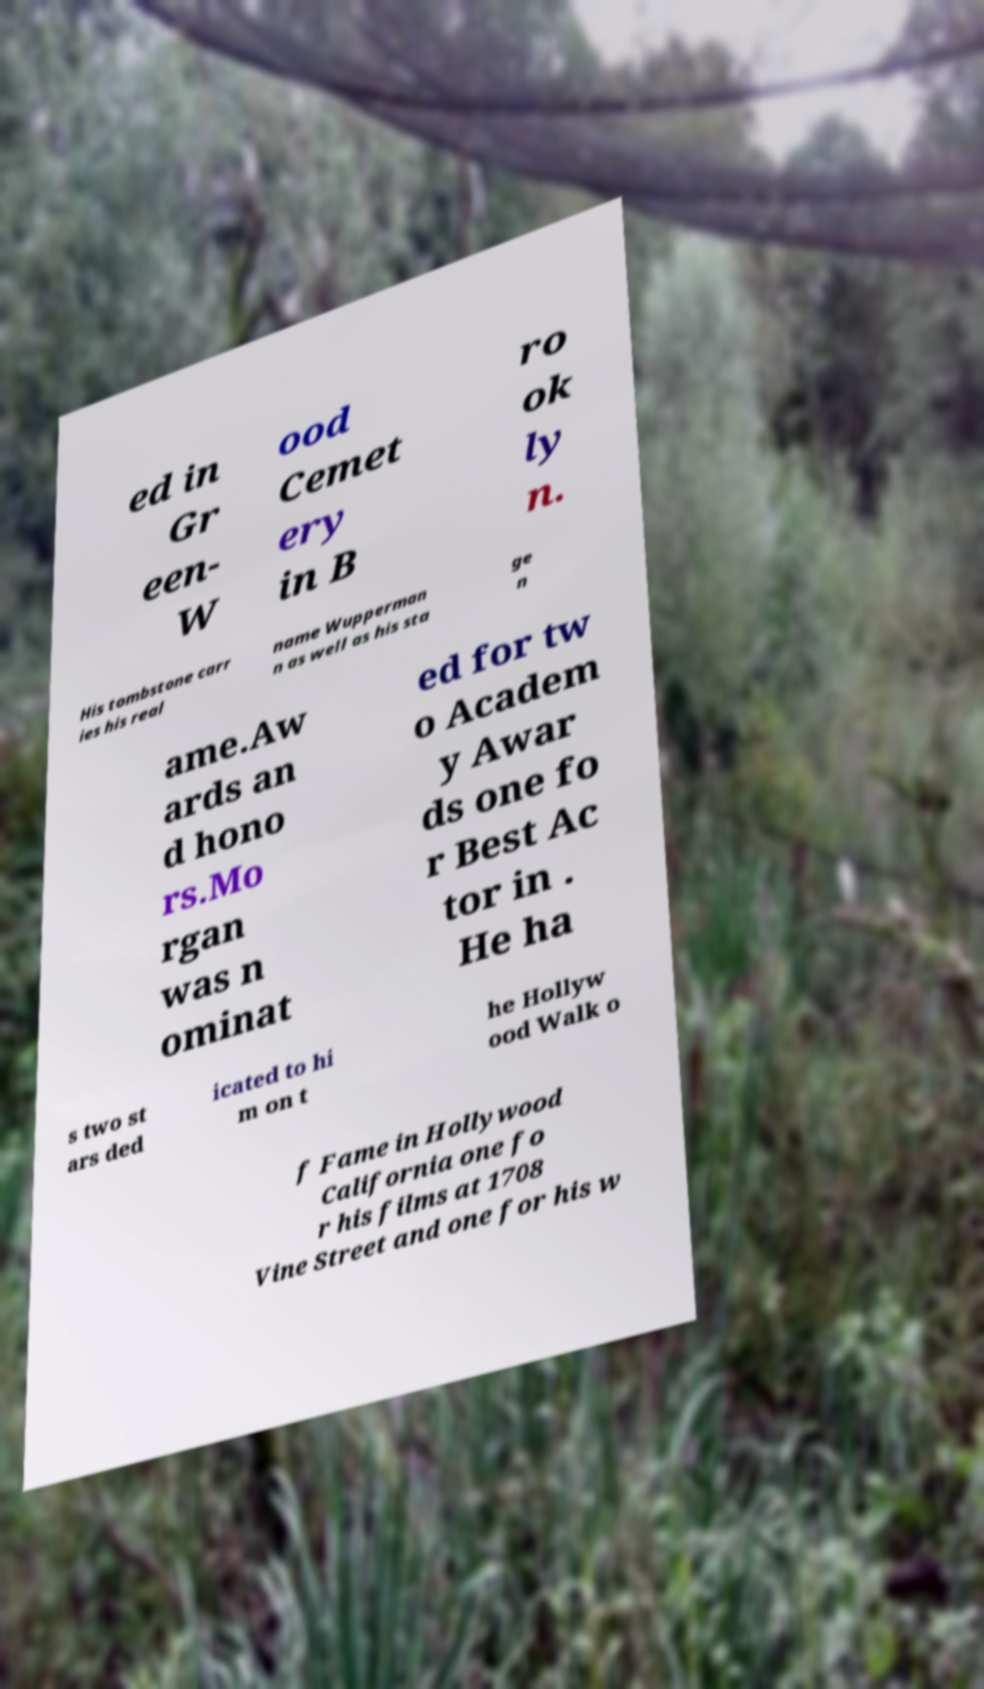Please read and relay the text visible in this image. What does it say? ed in Gr een- W ood Cemet ery in B ro ok ly n. His tombstone carr ies his real name Wupperman n as well as his sta ge n ame.Aw ards an d hono rs.Mo rgan was n ominat ed for tw o Academ y Awar ds one fo r Best Ac tor in . He ha s two st ars ded icated to hi m on t he Hollyw ood Walk o f Fame in Hollywood California one fo r his films at 1708 Vine Street and one for his w 